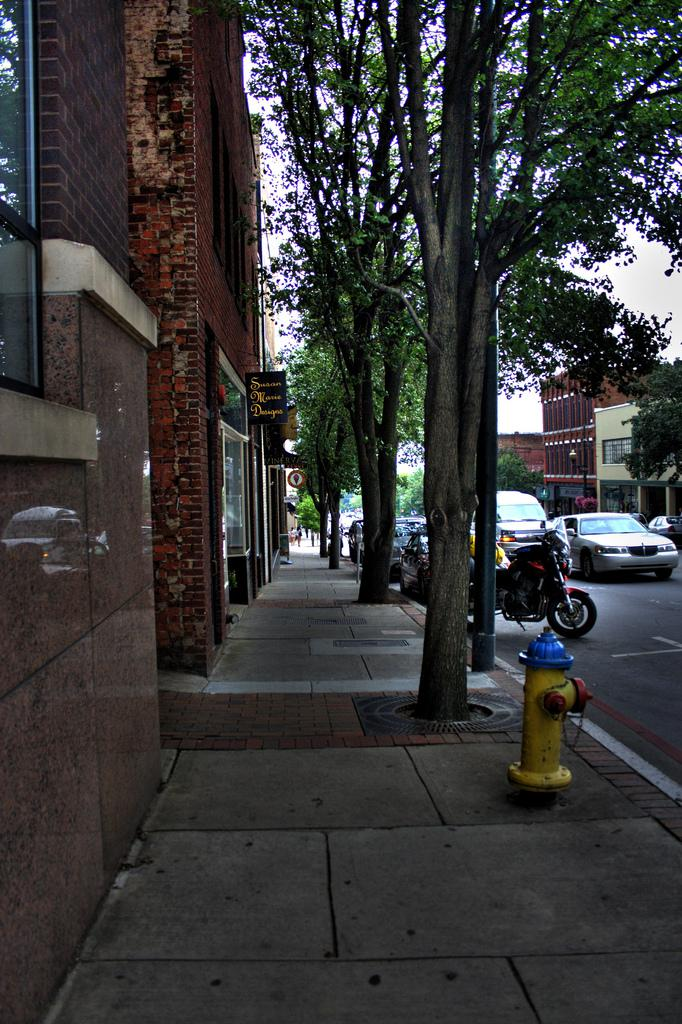Question: what is on the sidewalk?
Choices:
A. Chalk drawings.
B. A fire hydrant.
C. Bikes.
D. Newspapers.
Answer with the letter. Answer: B Question: where is the motorcycle?
Choices:
A. On the bridge.
B. In the back of the truck.
C. In the store.
D. On the street.
Answer with the letter. Answer: D Question: what is on the sidewalk along the street?
Choices:
A. Cracks.
B. Trees.
C. Paint.
D. Tar.
Answer with the letter. Answer: B Question: how full is the sidewalk?
Choices:
A. There is no room left to walk.
B. It is empty.
C. Only 3 people using it.
D. Only half full.
Answer with the letter. Answer: B Question: what is the sidewalk next to?
Choices:
A. Street.
B. Grass.
C. Buildings.
D. Corner.
Answer with the letter. Answer: C Question: what type of plants are on the sidewalk?
Choices:
A. Flowers.
B. Weeds.
C. Trees.
D. Grass.
Answer with the letter. Answer: C Question: what is the building made of with the sign on it?
Choices:
A. Brick.
B. Wood.
C. Plastic.
D. Cardboard.
Answer with the letter. Answer: A Question: how many colors are on the fire hydrant?
Choices:
A. Three.
B. Two.
C. One.
D. Four.
Answer with the letter. Answer: A Question: where are the trees?
Choices:
A. In the front lawn.
B. At the park.
C. On the left.
D. Near the trail.
Answer with the letter. Answer: C Question: what kind of parking is available?
Choices:
A. Free parking.
B. Road side parking.
C. Metered parking.
D. Paralell parking.
Answer with the letter. Answer: C Question: when is this taken?
Choices:
A. At sunrise.
B. During the day.
C. At dusk.
D. Late night.
Answer with the letter. Answer: B Question: how does the street look?
Choices:
A. Shadowy.
B. Dusty.
C. Sunny.
D. Dirty.
Answer with the letter. Answer: A Question: how much litter is on the ground?
Choices:
A. One piece.
B. None.
C. Several piles.
D. A few pieces here and there.
Answer with the letter. Answer: B Question: what else is there besides concrete?
Choices:
A. Asphalt.
B. Wood.
C. Bricks.
D. Metal.
Answer with the letter. Answer: C Question: when is the picture taken?
Choices:
A. During the day.
B. Fall.
C. At night.
D. During the holidays.
Answer with the letter. Answer: A 